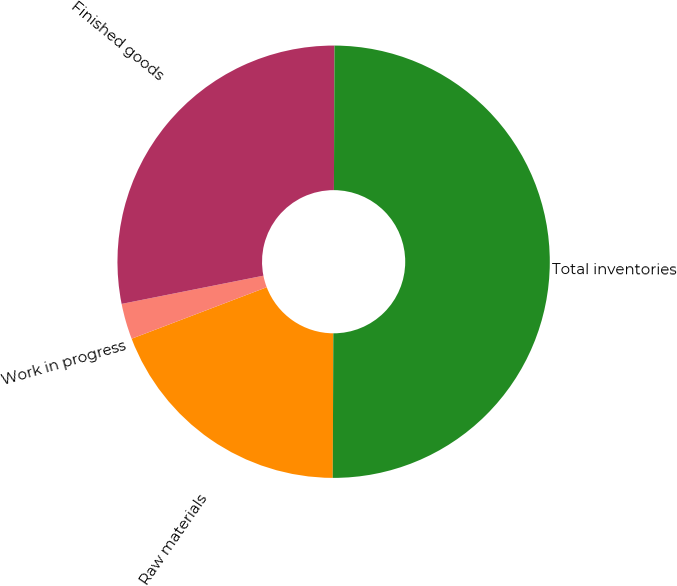Convert chart to OTSL. <chart><loc_0><loc_0><loc_500><loc_500><pie_chart><fcel>Raw materials<fcel>Work in progress<fcel>Finished goods<fcel>Total inventories<nl><fcel>19.14%<fcel>2.67%<fcel>28.19%<fcel>50.0%<nl></chart> 